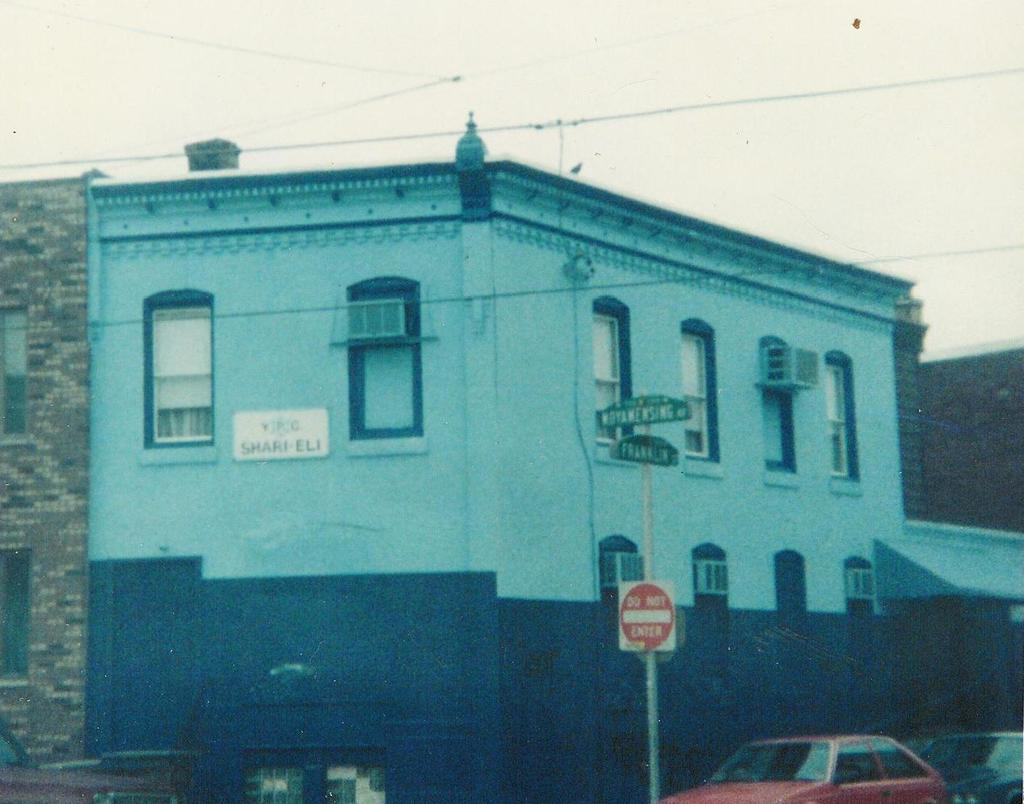<image>
Offer a succinct explanation of the picture presented. a sign that says do not enter on it next to a building 